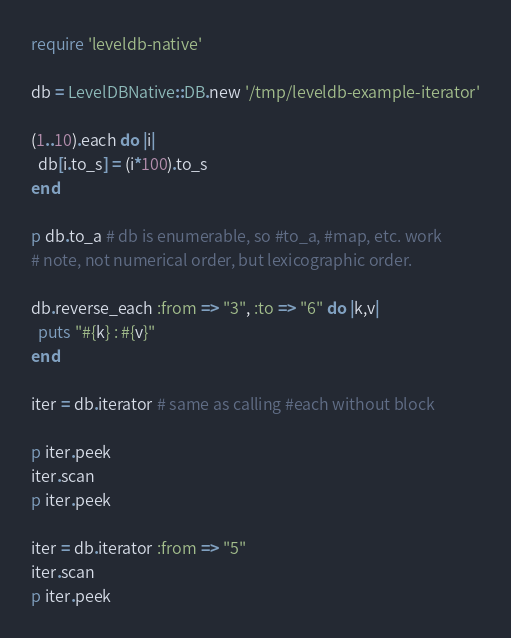Convert code to text. <code><loc_0><loc_0><loc_500><loc_500><_Ruby_>require 'leveldb-native'

db = LevelDBNative::DB.new '/tmp/leveldb-example-iterator'

(1..10).each do |i|
  db[i.to_s] = (i*100).to_s
end

p db.to_a # db is enumerable, so #to_a, #map, etc. work
# note, not numerical order, but lexicographic order.

db.reverse_each :from => "3", :to => "6" do |k,v|
  puts "#{k} : #{v}"
end

iter = db.iterator # same as calling #each without block

p iter.peek
iter.scan
p iter.peek

iter = db.iterator :from => "5"
iter.scan
p iter.peek
</code> 